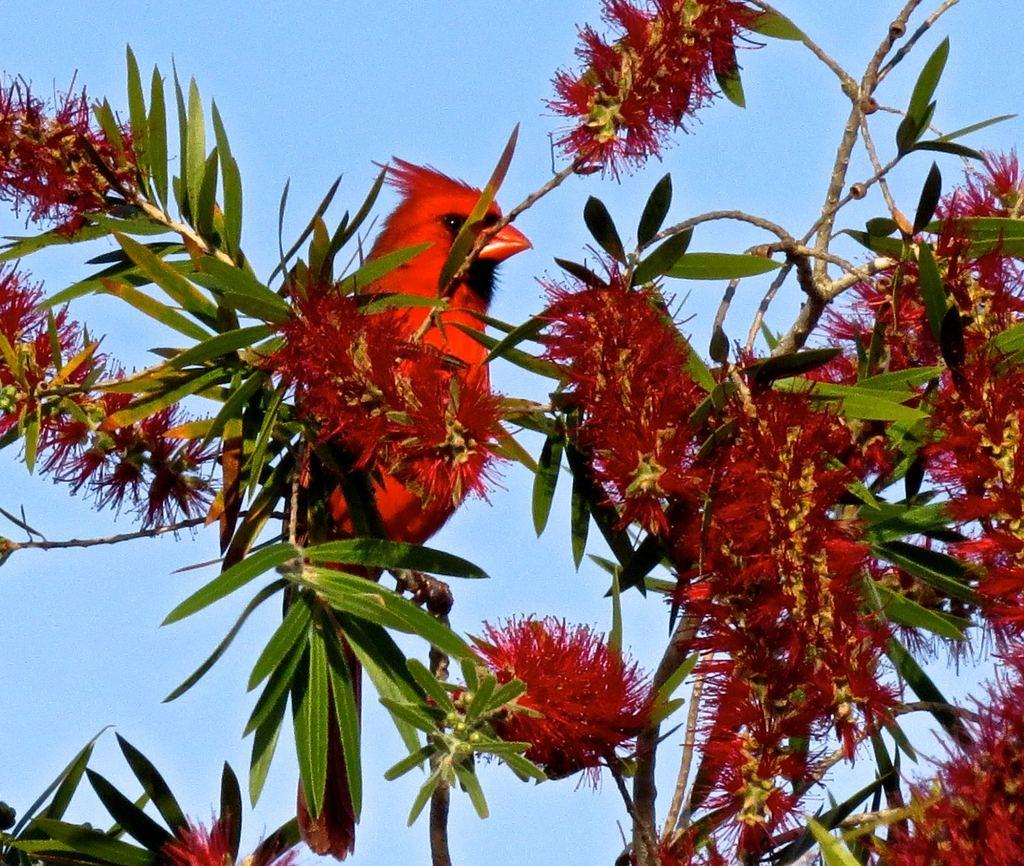What is the main subject in the center of the image? There is a bird on a tree in the center of the image. What other elements can be seen in the image? There are flowers in the image. What can be seen in the background of the image? The sky is visible in the background of the image. What flavor of whip can be seen in the image? There is no whip present in the image, so it is not possible to determine its flavor. 